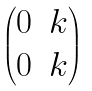<formula> <loc_0><loc_0><loc_500><loc_500>\begin{pmatrix} 0 & k \\ 0 & k \end{pmatrix}</formula> 